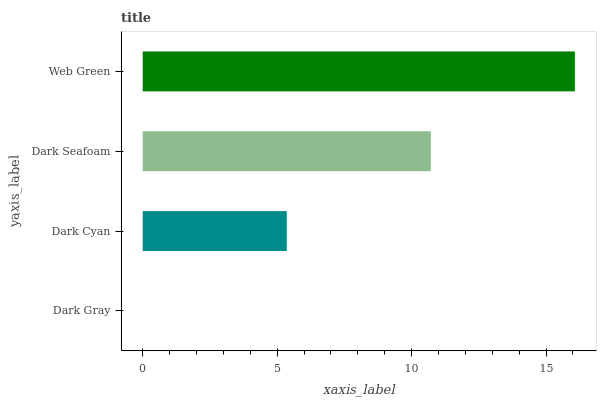Is Dark Gray the minimum?
Answer yes or no. Yes. Is Web Green the maximum?
Answer yes or no. Yes. Is Dark Cyan the minimum?
Answer yes or no. No. Is Dark Cyan the maximum?
Answer yes or no. No. Is Dark Cyan greater than Dark Gray?
Answer yes or no. Yes. Is Dark Gray less than Dark Cyan?
Answer yes or no. Yes. Is Dark Gray greater than Dark Cyan?
Answer yes or no. No. Is Dark Cyan less than Dark Gray?
Answer yes or no. No. Is Dark Seafoam the high median?
Answer yes or no. Yes. Is Dark Cyan the low median?
Answer yes or no. Yes. Is Dark Gray the high median?
Answer yes or no. No. Is Dark Seafoam the low median?
Answer yes or no. No. 